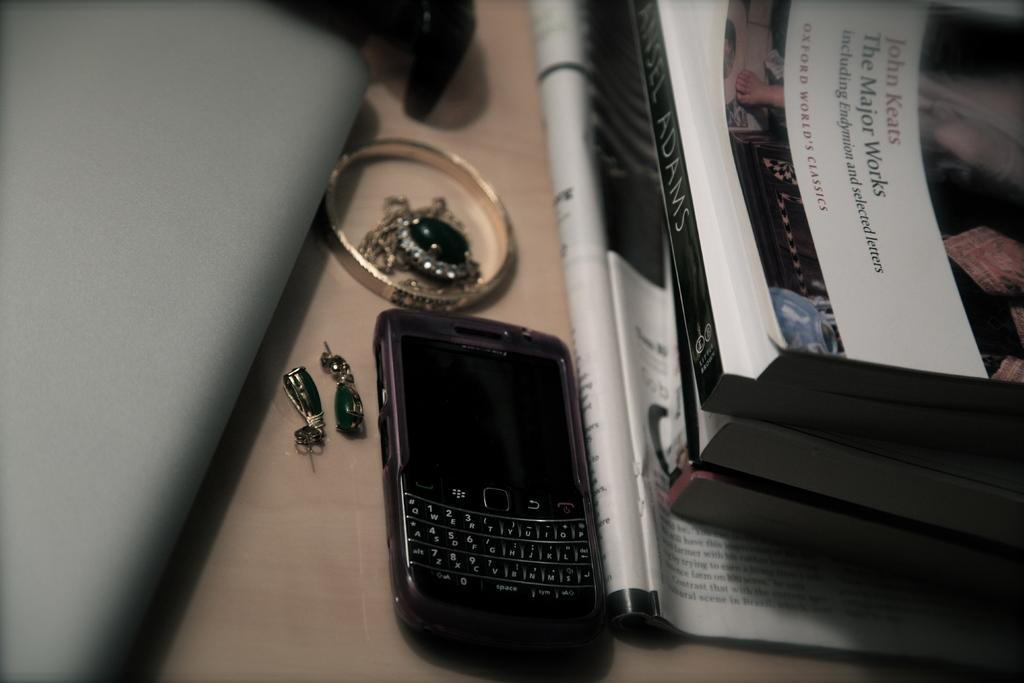<image>
Present a compact description of the photo's key features. A phone and jewelry sit on a desk next to a few books, one called The Major Works by John Keats 